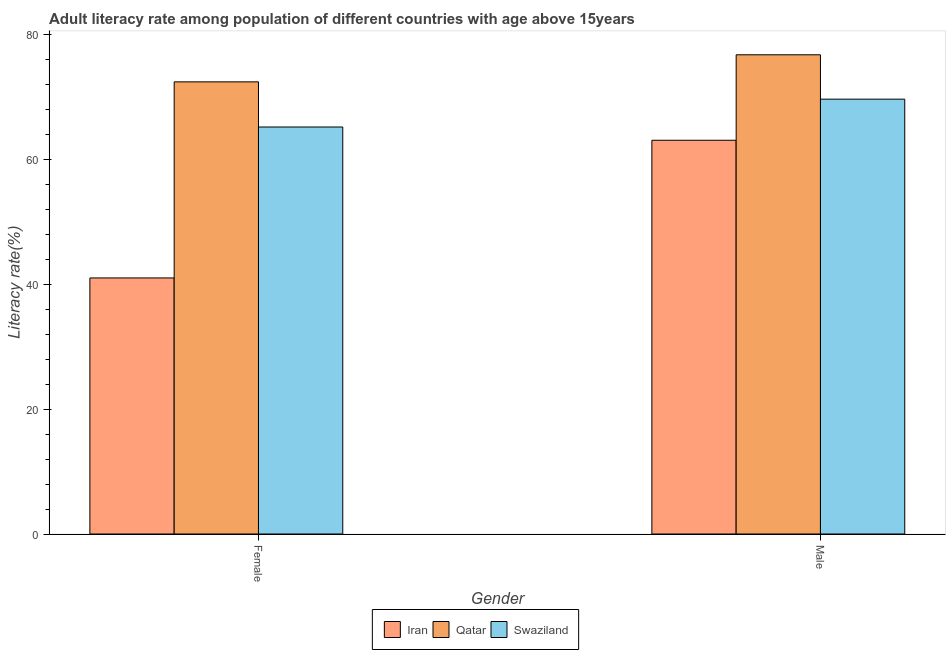How many different coloured bars are there?
Your response must be concise. 3. How many groups of bars are there?
Make the answer very short. 2. What is the label of the 2nd group of bars from the left?
Ensure brevity in your answer.  Male. What is the female adult literacy rate in Qatar?
Ensure brevity in your answer.  72.46. Across all countries, what is the maximum female adult literacy rate?
Your answer should be very brief. 72.46. Across all countries, what is the minimum female adult literacy rate?
Offer a terse response. 41.03. In which country was the female adult literacy rate maximum?
Your response must be concise. Qatar. In which country was the male adult literacy rate minimum?
Keep it short and to the point. Iran. What is the total female adult literacy rate in the graph?
Offer a very short reply. 178.72. What is the difference between the male adult literacy rate in Swaziland and that in Iran?
Ensure brevity in your answer.  6.58. What is the difference between the female adult literacy rate in Iran and the male adult literacy rate in Swaziland?
Your response must be concise. -28.65. What is the average male adult literacy rate per country?
Your response must be concise. 69.86. What is the difference between the female adult literacy rate and male adult literacy rate in Qatar?
Your response must be concise. -4.34. What is the ratio of the female adult literacy rate in Iran to that in Swaziland?
Your answer should be very brief. 0.63. Is the female adult literacy rate in Iran less than that in Qatar?
Your answer should be very brief. Yes. In how many countries, is the male adult literacy rate greater than the average male adult literacy rate taken over all countries?
Your answer should be very brief. 1. What does the 1st bar from the left in Female represents?
Your answer should be compact. Iran. What does the 2nd bar from the right in Male represents?
Offer a terse response. Qatar. Are all the bars in the graph horizontal?
Your answer should be very brief. No. Does the graph contain any zero values?
Offer a very short reply. No. Does the graph contain grids?
Offer a very short reply. No. Where does the legend appear in the graph?
Offer a terse response. Bottom center. How are the legend labels stacked?
Your answer should be compact. Horizontal. What is the title of the graph?
Your answer should be compact. Adult literacy rate among population of different countries with age above 15years. What is the label or title of the X-axis?
Provide a succinct answer. Gender. What is the label or title of the Y-axis?
Give a very brief answer. Literacy rate(%). What is the Literacy rate(%) in Iran in Female?
Your answer should be compact. 41.03. What is the Literacy rate(%) in Qatar in Female?
Keep it short and to the point. 72.46. What is the Literacy rate(%) of Swaziland in Female?
Give a very brief answer. 65.22. What is the Literacy rate(%) of Iran in Male?
Give a very brief answer. 63.1. What is the Literacy rate(%) of Qatar in Male?
Give a very brief answer. 76.8. What is the Literacy rate(%) of Swaziland in Male?
Your answer should be very brief. 69.68. Across all Gender, what is the maximum Literacy rate(%) of Iran?
Give a very brief answer. 63.1. Across all Gender, what is the maximum Literacy rate(%) in Qatar?
Provide a short and direct response. 76.8. Across all Gender, what is the maximum Literacy rate(%) in Swaziland?
Ensure brevity in your answer.  69.68. Across all Gender, what is the minimum Literacy rate(%) of Iran?
Provide a short and direct response. 41.03. Across all Gender, what is the minimum Literacy rate(%) in Qatar?
Provide a short and direct response. 72.46. Across all Gender, what is the minimum Literacy rate(%) of Swaziland?
Make the answer very short. 65.22. What is the total Literacy rate(%) in Iran in the graph?
Your answer should be compact. 104.13. What is the total Literacy rate(%) in Qatar in the graph?
Provide a short and direct response. 149.25. What is the total Literacy rate(%) of Swaziland in the graph?
Give a very brief answer. 134.91. What is the difference between the Literacy rate(%) of Iran in Female and that in Male?
Your answer should be compact. -22.07. What is the difference between the Literacy rate(%) in Qatar in Female and that in Male?
Keep it short and to the point. -4.34. What is the difference between the Literacy rate(%) in Swaziland in Female and that in Male?
Your answer should be compact. -4.46. What is the difference between the Literacy rate(%) in Iran in Female and the Literacy rate(%) in Qatar in Male?
Offer a terse response. -35.76. What is the difference between the Literacy rate(%) of Iran in Female and the Literacy rate(%) of Swaziland in Male?
Your response must be concise. -28.65. What is the difference between the Literacy rate(%) of Qatar in Female and the Literacy rate(%) of Swaziland in Male?
Your response must be concise. 2.78. What is the average Literacy rate(%) of Iran per Gender?
Make the answer very short. 52.07. What is the average Literacy rate(%) of Qatar per Gender?
Give a very brief answer. 74.63. What is the average Literacy rate(%) in Swaziland per Gender?
Your answer should be compact. 67.45. What is the difference between the Literacy rate(%) of Iran and Literacy rate(%) of Qatar in Female?
Your response must be concise. -31.43. What is the difference between the Literacy rate(%) in Iran and Literacy rate(%) in Swaziland in Female?
Make the answer very short. -24.19. What is the difference between the Literacy rate(%) in Qatar and Literacy rate(%) in Swaziland in Female?
Offer a very short reply. 7.24. What is the difference between the Literacy rate(%) in Iran and Literacy rate(%) in Qatar in Male?
Keep it short and to the point. -13.7. What is the difference between the Literacy rate(%) in Iran and Literacy rate(%) in Swaziland in Male?
Give a very brief answer. -6.58. What is the difference between the Literacy rate(%) in Qatar and Literacy rate(%) in Swaziland in Male?
Offer a terse response. 7.11. What is the ratio of the Literacy rate(%) of Iran in Female to that in Male?
Your answer should be very brief. 0.65. What is the ratio of the Literacy rate(%) in Qatar in Female to that in Male?
Ensure brevity in your answer.  0.94. What is the ratio of the Literacy rate(%) in Swaziland in Female to that in Male?
Your answer should be compact. 0.94. What is the difference between the highest and the second highest Literacy rate(%) in Iran?
Provide a short and direct response. 22.07. What is the difference between the highest and the second highest Literacy rate(%) in Qatar?
Your answer should be very brief. 4.34. What is the difference between the highest and the second highest Literacy rate(%) of Swaziland?
Offer a very short reply. 4.46. What is the difference between the highest and the lowest Literacy rate(%) in Iran?
Keep it short and to the point. 22.07. What is the difference between the highest and the lowest Literacy rate(%) of Qatar?
Offer a terse response. 4.34. What is the difference between the highest and the lowest Literacy rate(%) in Swaziland?
Your answer should be compact. 4.46. 